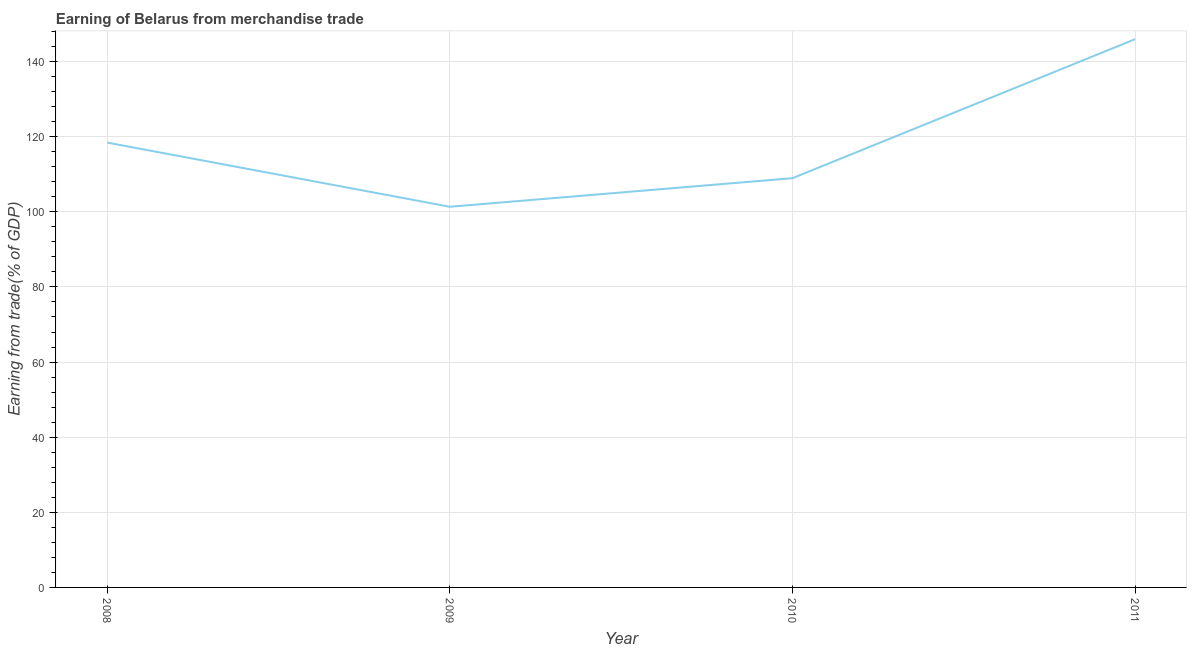What is the earning from merchandise trade in 2008?
Your response must be concise. 118.44. Across all years, what is the maximum earning from merchandise trade?
Offer a very short reply. 145.96. Across all years, what is the minimum earning from merchandise trade?
Provide a succinct answer. 101.35. What is the sum of the earning from merchandise trade?
Your answer should be very brief. 474.71. What is the difference between the earning from merchandise trade in 2009 and 2011?
Keep it short and to the point. -44.61. What is the average earning from merchandise trade per year?
Make the answer very short. 118.68. What is the median earning from merchandise trade?
Offer a very short reply. 113.7. What is the ratio of the earning from merchandise trade in 2009 to that in 2011?
Offer a very short reply. 0.69. Is the earning from merchandise trade in 2008 less than that in 2011?
Offer a very short reply. Yes. What is the difference between the highest and the second highest earning from merchandise trade?
Your answer should be very brief. 27.53. Is the sum of the earning from merchandise trade in 2009 and 2011 greater than the maximum earning from merchandise trade across all years?
Ensure brevity in your answer.  Yes. What is the difference between the highest and the lowest earning from merchandise trade?
Make the answer very short. 44.61. In how many years, is the earning from merchandise trade greater than the average earning from merchandise trade taken over all years?
Offer a very short reply. 1. Does the earning from merchandise trade monotonically increase over the years?
Offer a very short reply. No. How many lines are there?
Provide a succinct answer. 1. What is the difference between two consecutive major ticks on the Y-axis?
Provide a short and direct response. 20. What is the title of the graph?
Your answer should be compact. Earning of Belarus from merchandise trade. What is the label or title of the X-axis?
Keep it short and to the point. Year. What is the label or title of the Y-axis?
Make the answer very short. Earning from trade(% of GDP). What is the Earning from trade(% of GDP) of 2008?
Make the answer very short. 118.44. What is the Earning from trade(% of GDP) of 2009?
Make the answer very short. 101.35. What is the Earning from trade(% of GDP) of 2010?
Keep it short and to the point. 108.96. What is the Earning from trade(% of GDP) in 2011?
Provide a succinct answer. 145.96. What is the difference between the Earning from trade(% of GDP) in 2008 and 2009?
Your response must be concise. 17.08. What is the difference between the Earning from trade(% of GDP) in 2008 and 2010?
Your answer should be compact. 9.48. What is the difference between the Earning from trade(% of GDP) in 2008 and 2011?
Provide a short and direct response. -27.53. What is the difference between the Earning from trade(% of GDP) in 2009 and 2010?
Make the answer very short. -7.61. What is the difference between the Earning from trade(% of GDP) in 2009 and 2011?
Offer a terse response. -44.61. What is the difference between the Earning from trade(% of GDP) in 2010 and 2011?
Offer a terse response. -37. What is the ratio of the Earning from trade(% of GDP) in 2008 to that in 2009?
Ensure brevity in your answer.  1.17. What is the ratio of the Earning from trade(% of GDP) in 2008 to that in 2010?
Your answer should be very brief. 1.09. What is the ratio of the Earning from trade(% of GDP) in 2008 to that in 2011?
Offer a very short reply. 0.81. What is the ratio of the Earning from trade(% of GDP) in 2009 to that in 2010?
Offer a very short reply. 0.93. What is the ratio of the Earning from trade(% of GDP) in 2009 to that in 2011?
Give a very brief answer. 0.69. What is the ratio of the Earning from trade(% of GDP) in 2010 to that in 2011?
Keep it short and to the point. 0.75. 